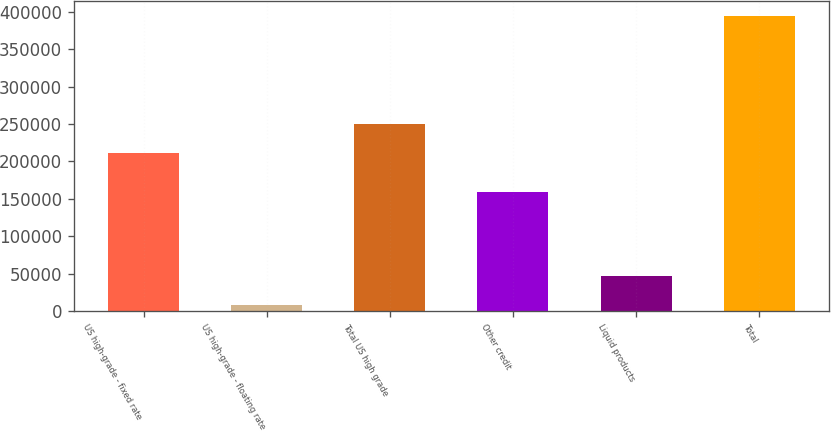<chart> <loc_0><loc_0><loc_500><loc_500><bar_chart><fcel>US high-grade - fixed rate<fcel>US high-grade - floating rate<fcel>Total US high grade<fcel>Other credit<fcel>Liquid products<fcel>Total<nl><fcel>211974<fcel>7420<fcel>250674<fcel>159724<fcel>46120.4<fcel>394424<nl></chart> 